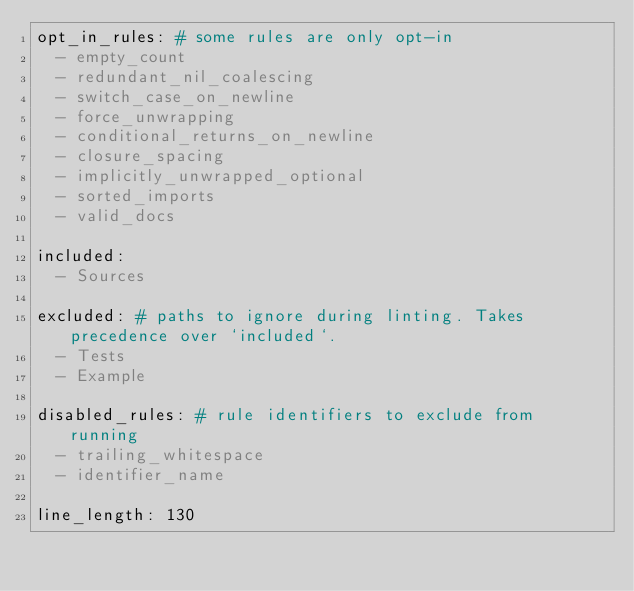Convert code to text. <code><loc_0><loc_0><loc_500><loc_500><_YAML_>opt_in_rules: # some rules are only opt-in
  - empty_count
  - redundant_nil_coalescing
  - switch_case_on_newline
  - force_unwrapping
  - conditional_returns_on_newline
  - closure_spacing
  - implicitly_unwrapped_optional
  - sorted_imports
  - valid_docs

included:
  - Sources

excluded: # paths to ignore during linting. Takes precedence over `included`.
  - Tests
  - Example

disabled_rules: # rule identifiers to exclude from running
  - trailing_whitespace
  - identifier_name

line_length: 130</code> 